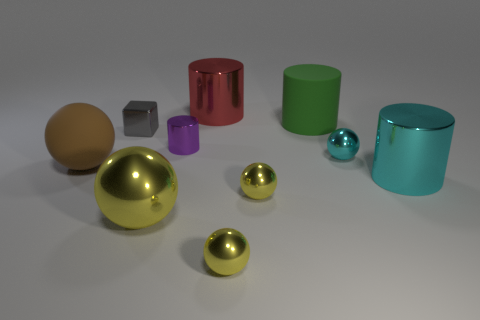Are there any tiny metallic spheres of the same color as the large shiny ball?
Offer a terse response. Yes. What size is the sphere on the right side of the large matte thing to the right of the yellow metal ball that is left of the purple thing?
Your response must be concise. Small. Are there fewer purple shiny things left of the tiny block than small yellow things that are left of the small cyan ball?
Offer a terse response. Yes. What number of big red objects have the same material as the large brown thing?
Your answer should be compact. 0. There is a yellow metal ball that is to the right of the small metal thing in front of the large metal ball; are there any spheres that are in front of it?
Make the answer very short. Yes. What shape is the object that is the same material as the large brown sphere?
Keep it short and to the point. Cylinder. Are there more big metal cylinders than yellow shiny objects?
Keep it short and to the point. No. Is the shape of the tiny cyan metallic object the same as the big thing that is left of the tiny cube?
Make the answer very short. Yes. What material is the green cylinder?
Make the answer very short. Rubber. What color is the large shiny cylinder that is behind the large cylinder in front of the sphere on the left side of the gray object?
Provide a succinct answer. Red. 